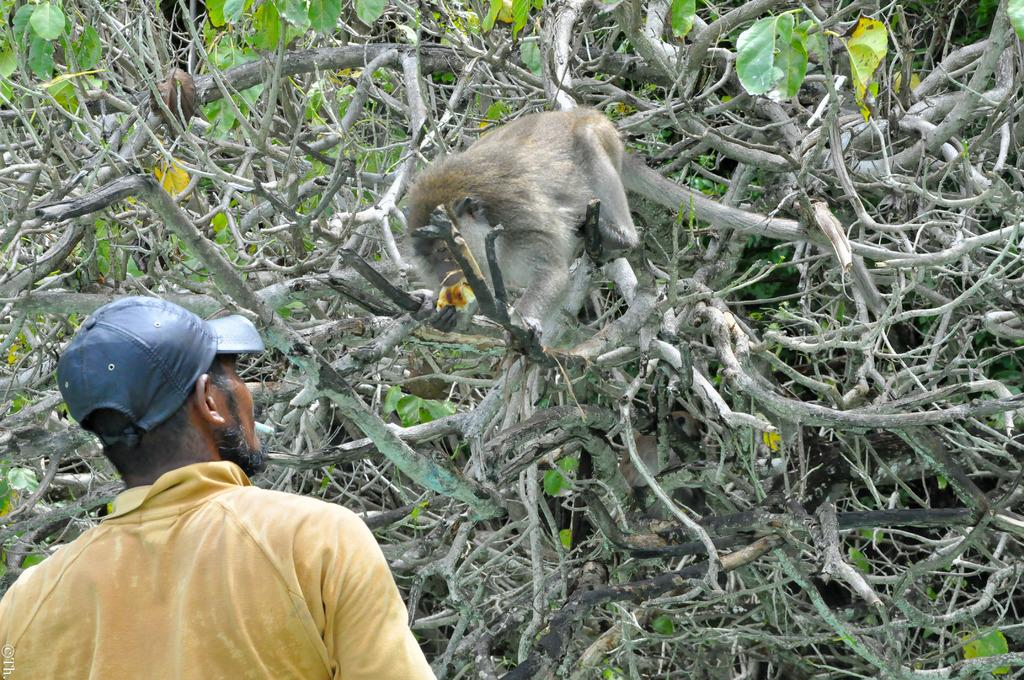What animal is present in the image? There is a monkey in the image. Where is the monkey located? The monkey is on a tree. What is the man wearing in the image? The man is wearing a yellow shirt and a cap. What can be seen in the background of the image? There are many trees in the background of the image. What type of fear does the monkey have in the image? There is no indication of fear in the image; the monkey is simply sitting on a tree. How many legs does the monkey have in the image? The monkey has four legs in the image, as it is an animal with two arms and two legs. 